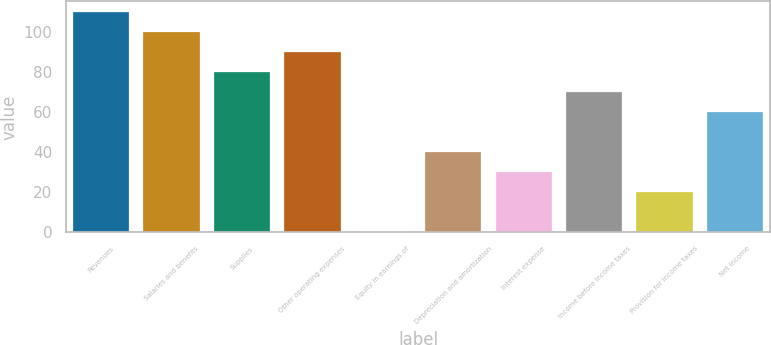Convert chart. <chart><loc_0><loc_0><loc_500><loc_500><bar_chart><fcel>Revenues<fcel>Salaries and benefits<fcel>Supplies<fcel>Other operating expenses<fcel>Equity in earnings of<fcel>Depreciation and amortization<fcel>Interest expense<fcel>Income before income taxes<fcel>Provision for income taxes<fcel>Net income<nl><fcel>109.99<fcel>100<fcel>80.02<fcel>90.01<fcel>0.1<fcel>40.06<fcel>30.07<fcel>70.03<fcel>20.08<fcel>60.04<nl></chart> 